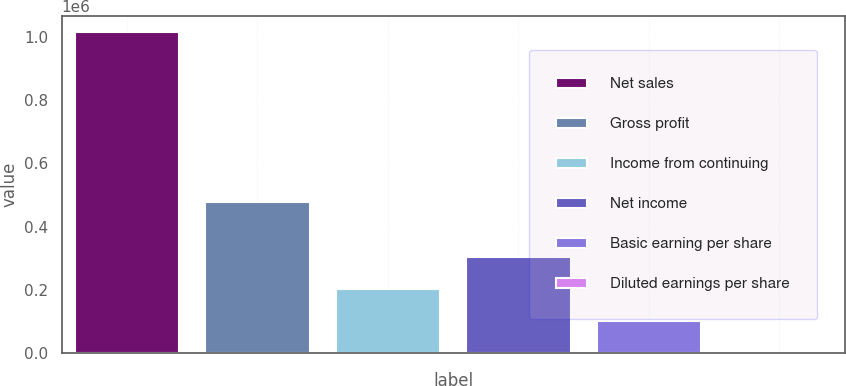<chart> <loc_0><loc_0><loc_500><loc_500><bar_chart><fcel>Net sales<fcel>Gross profit<fcel>Income from continuing<fcel>Net income<fcel>Basic earning per share<fcel>Diluted earnings per share<nl><fcel>1.01615e+06<fcel>478431<fcel>203230<fcel>304845<fcel>101615<fcel>0.33<nl></chart> 